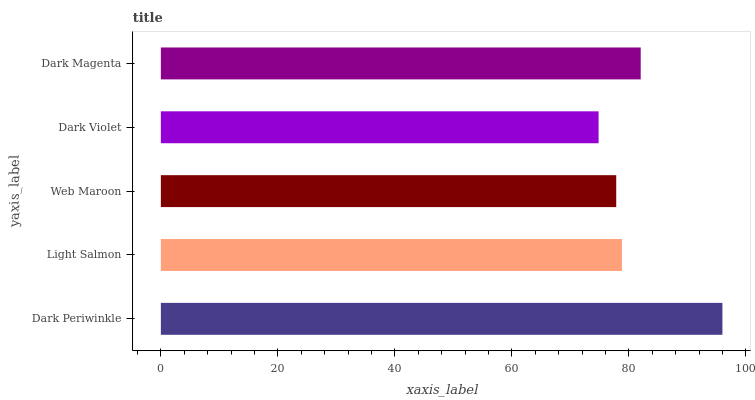Is Dark Violet the minimum?
Answer yes or no. Yes. Is Dark Periwinkle the maximum?
Answer yes or no. Yes. Is Light Salmon the minimum?
Answer yes or no. No. Is Light Salmon the maximum?
Answer yes or no. No. Is Dark Periwinkle greater than Light Salmon?
Answer yes or no. Yes. Is Light Salmon less than Dark Periwinkle?
Answer yes or no. Yes. Is Light Salmon greater than Dark Periwinkle?
Answer yes or no. No. Is Dark Periwinkle less than Light Salmon?
Answer yes or no. No. Is Light Salmon the high median?
Answer yes or no. Yes. Is Light Salmon the low median?
Answer yes or no. Yes. Is Dark Magenta the high median?
Answer yes or no. No. Is Dark Magenta the low median?
Answer yes or no. No. 